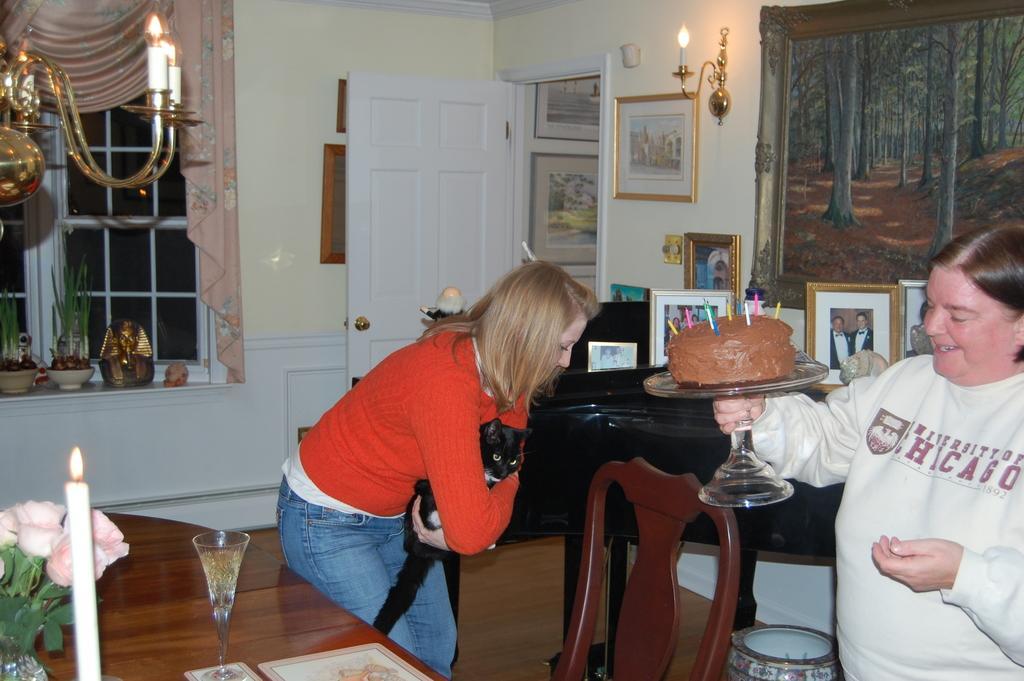Can you describe this image briefly? In this image, there are two persons. One person holding a cat and another person holding a cake. There is a table behind this person. This table contains glass, candle and flower vase. There is a chair behind this table. There is a door attached to the wall. This wall contains painting and photo frames. There is window contains curtains. 